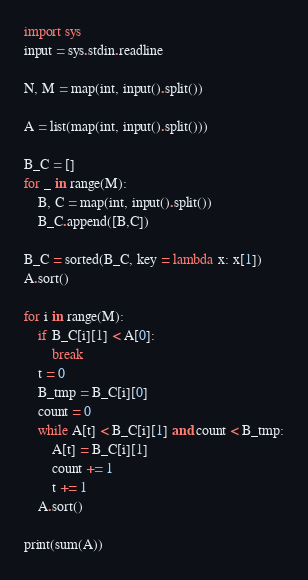<code> <loc_0><loc_0><loc_500><loc_500><_Python_>import sys
input = sys.stdin.readline

N, M = map(int, input().split())

A = list(map(int, input().split()))

B_C = []
for _ in range(M):
    B, C = map(int, input().split())
    B_C.append([B,C])

B_C = sorted(B_C, key = lambda x: x[1])
A.sort()

for i in range(M):
    if B_C[i][1] < A[0]:
        break
    t = 0
    B_tmp = B_C[i][0]
    count = 0
    while A[t] < B_C[i][1] and count < B_tmp:
        A[t] = B_C[i][1]
        count += 1
        t += 1
    A.sort()

print(sum(A))</code> 